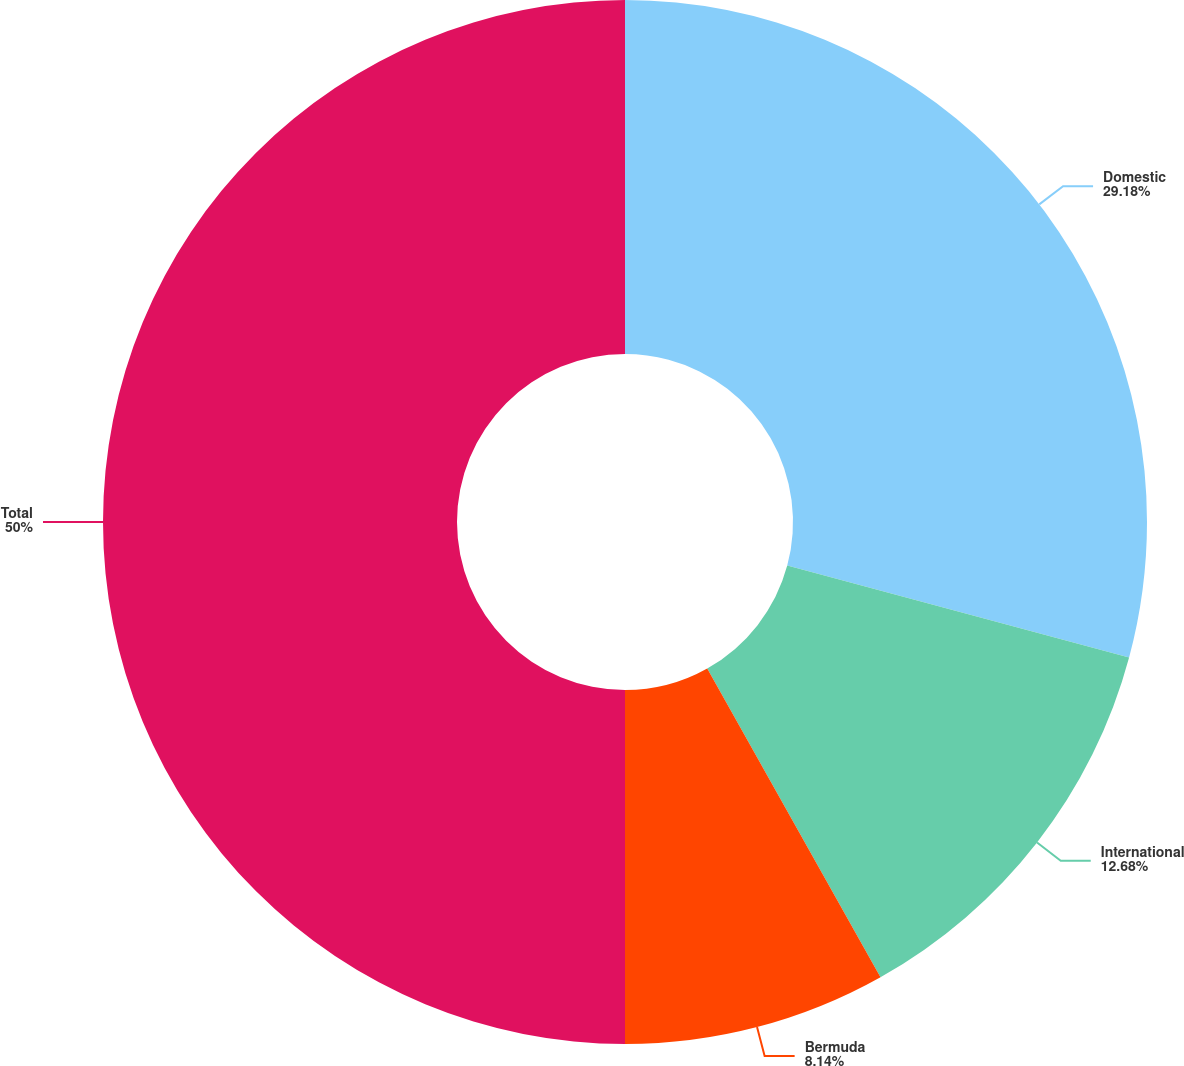Convert chart. <chart><loc_0><loc_0><loc_500><loc_500><pie_chart><fcel>Domestic<fcel>International<fcel>Bermuda<fcel>Total<nl><fcel>29.18%<fcel>12.68%<fcel>8.14%<fcel>50.0%<nl></chart> 